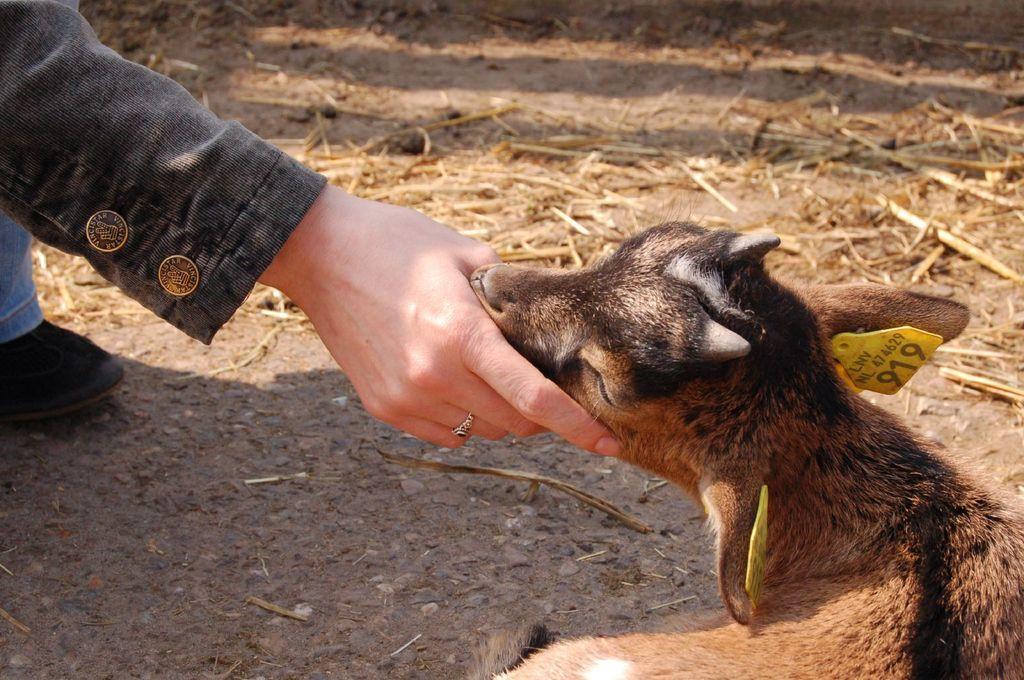How would you summarize this image in a sentence or two? In this picture we can see a person on the left side, on the right side there is an animal, we can see some grass in the background. 